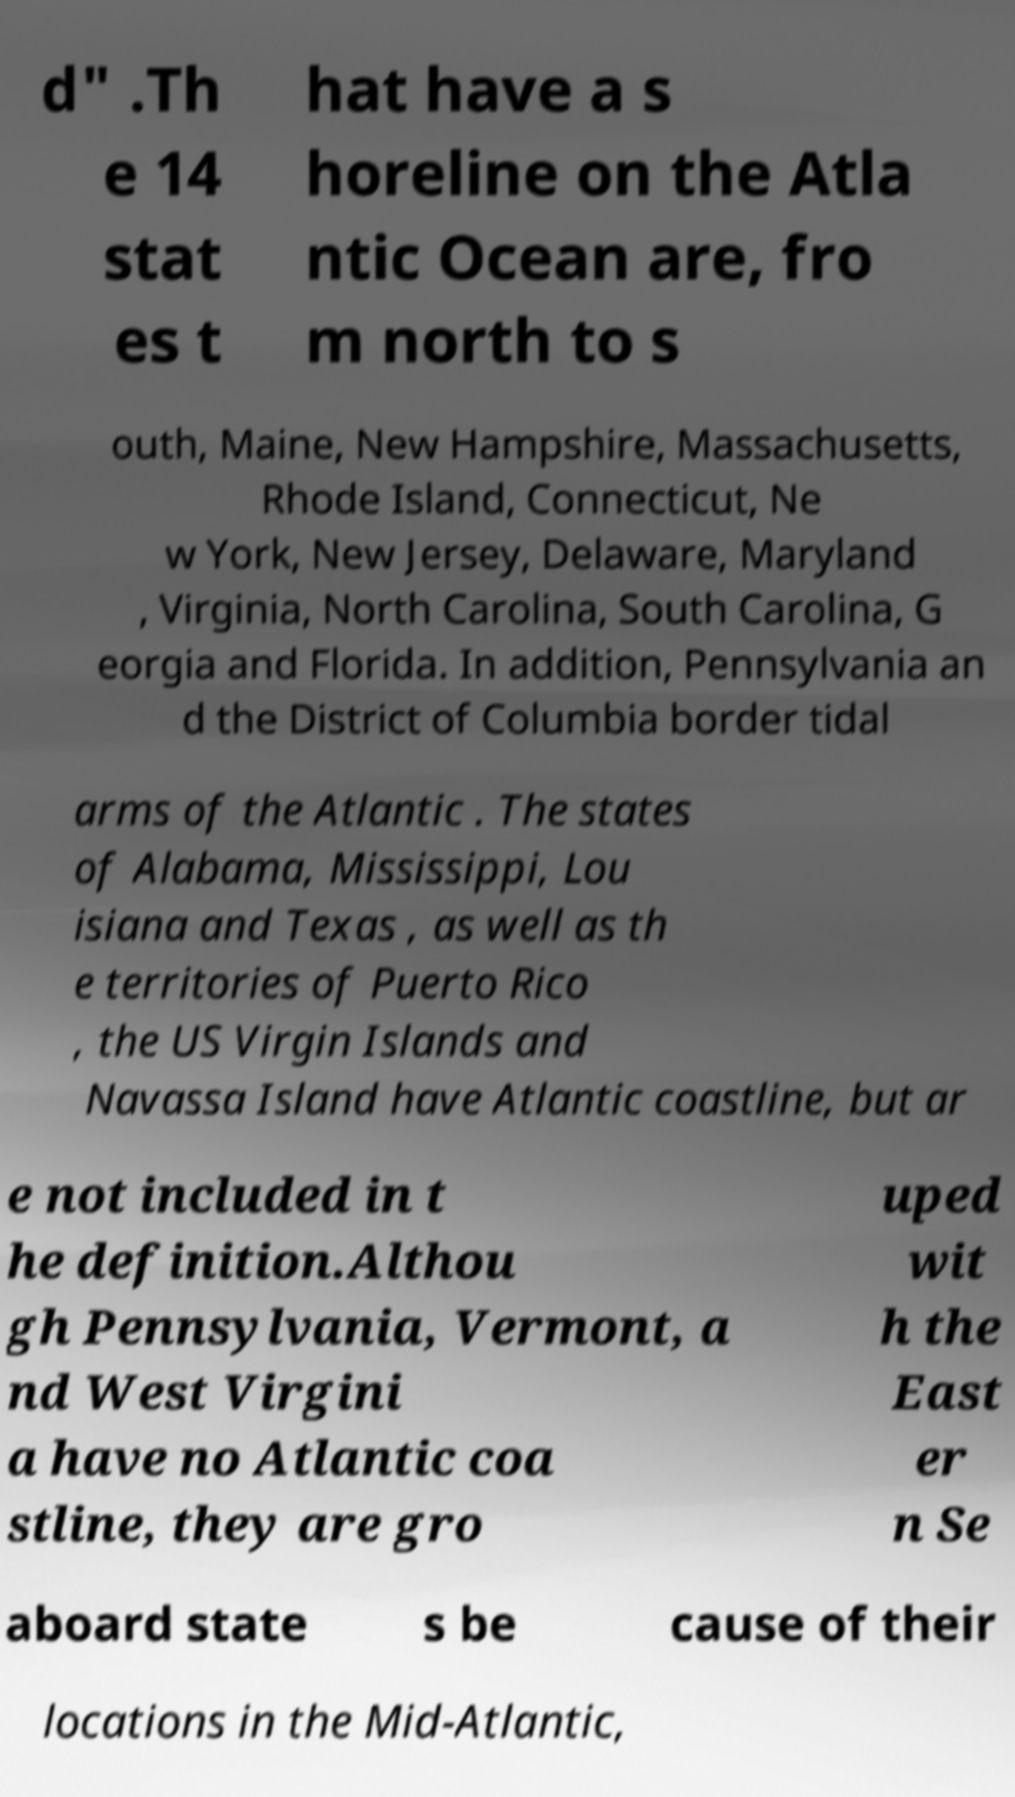I need the written content from this picture converted into text. Can you do that? d" .Th e 14 stat es t hat have a s horeline on the Atla ntic Ocean are, fro m north to s outh, Maine, New Hampshire, Massachusetts, Rhode Island, Connecticut, Ne w York, New Jersey, Delaware, Maryland , Virginia, North Carolina, South Carolina, G eorgia and Florida. In addition, Pennsylvania an d the District of Columbia border tidal arms of the Atlantic . The states of Alabama, Mississippi, Lou isiana and Texas , as well as th e territories of Puerto Rico , the US Virgin Islands and Navassa Island have Atlantic coastline, but ar e not included in t he definition.Althou gh Pennsylvania, Vermont, a nd West Virgini a have no Atlantic coa stline, they are gro uped wit h the East er n Se aboard state s be cause of their locations in the Mid-Atlantic, 